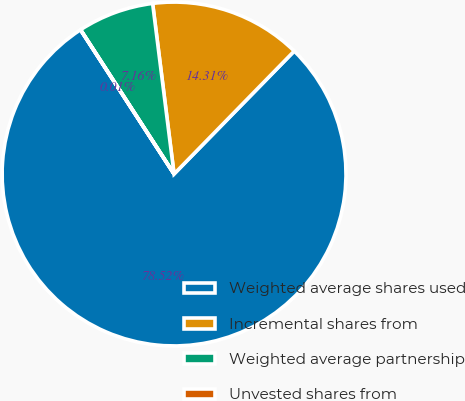Convert chart to OTSL. <chart><loc_0><loc_0><loc_500><loc_500><pie_chart><fcel>Weighted average shares used<fcel>Incremental shares from<fcel>Weighted average partnership<fcel>Unvested shares from<nl><fcel>78.53%<fcel>14.31%<fcel>7.16%<fcel>0.01%<nl></chart> 